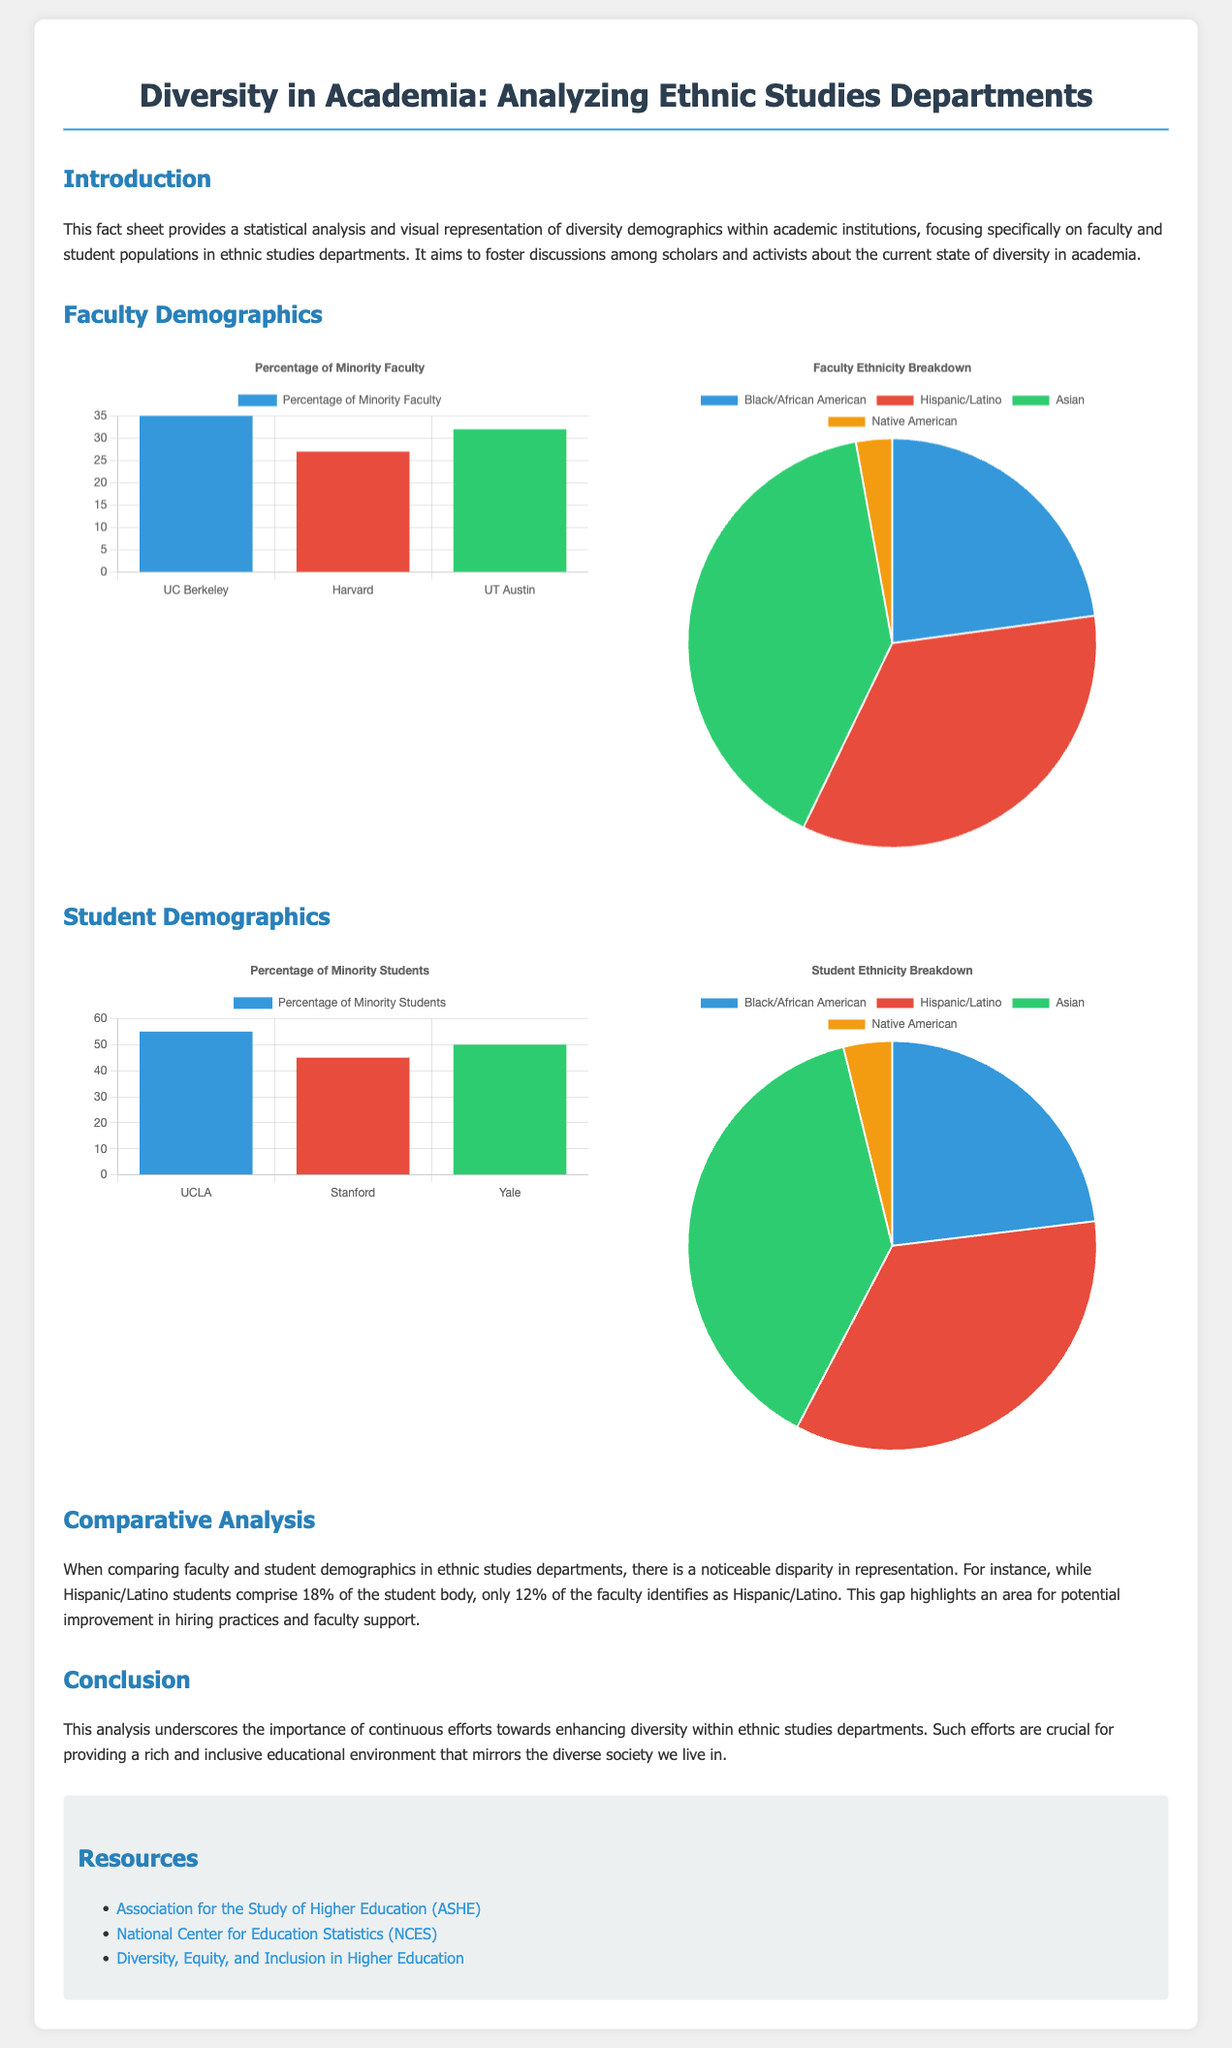What is the focus of the analysis? The analysis focuses specifically on faculty and student populations in ethnic studies departments.
Answer: Faculty and student populations in ethnic studies departments What percentage of Hispanic/Latino students is there in the student body? The document states that Hispanic/Latino students comprise 18% of the student body.
Answer: 18% What percentage of minority faculty does UC Berkeley have? The faculty bar chart indicates that UC Berkeley has 35% minority faculty.
Answer: 35% What is the percentage of Black/African American faculty? The faculty pie chart shows that 8% of the faculty identifies as Black/African American.
Answer: 8% Which university has the highest percentage of minority students? According to the student bar chart, UCLA has the highest percentage of minority students at 55%.
Answer: UCLA What is the percentage of minority faculty at Harvard? The document specifies that Harvard has 27% minority faculty.
Answer: 27% What is the aim of the fact sheet? The aim of the fact sheet is to foster discussions among scholars and activists about the current state of diversity in academia.
Answer: Foster discussions on diversity in academia Which resource focuses on higher education diversity? The document lists the "Diversity, Equity, and Inclusion in Higher Education" as a resource.
Answer: Diversity, Equity, and Inclusion in Higher Education How many groups are represented in the faculty pie chart? The faculty pie chart represents four groups: Black/African American, Hispanic/Latino, Asian, and Native American.
Answer: Four groups 